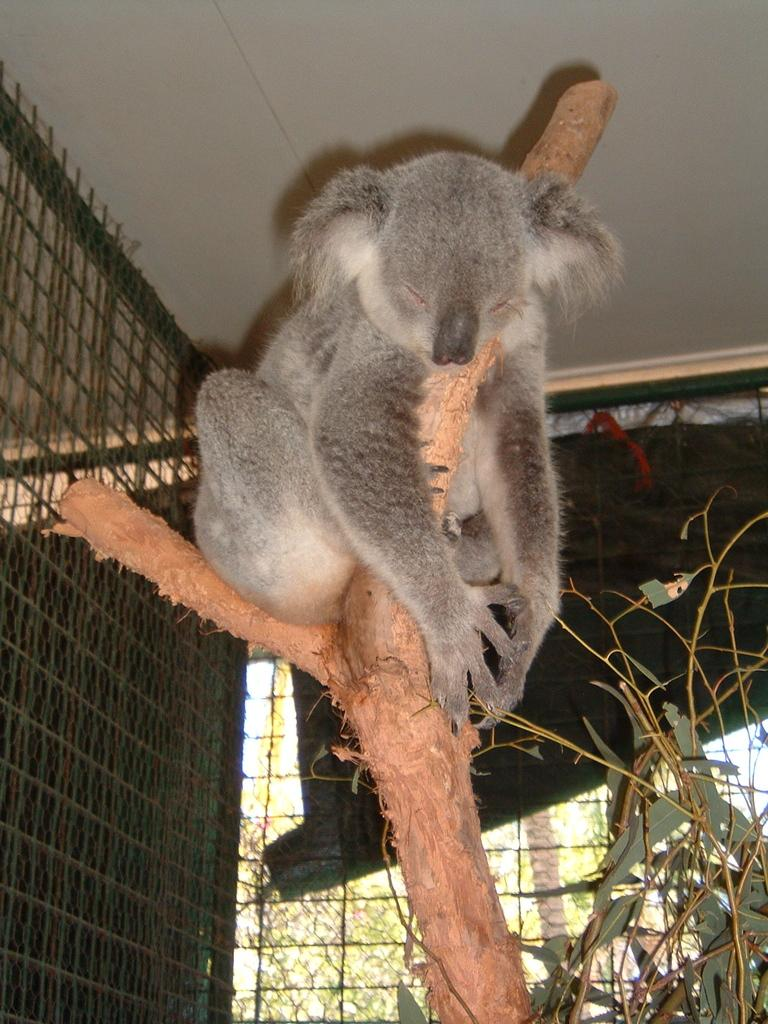What animal is in the image? There is a koala in the image. Where is the koala located? The koala is on a tree branch. What is the koala doing with the tree branch? The koala is holding the tree branch. Who else is visible in the image? There is a girl visible in the image. What type of vegetation can be seen in the image? There are trees visible in the image. What type of cheese is the goat eating in the image? There is no goat or cheese present in the image; it features a koala on a tree branch and a girl. 